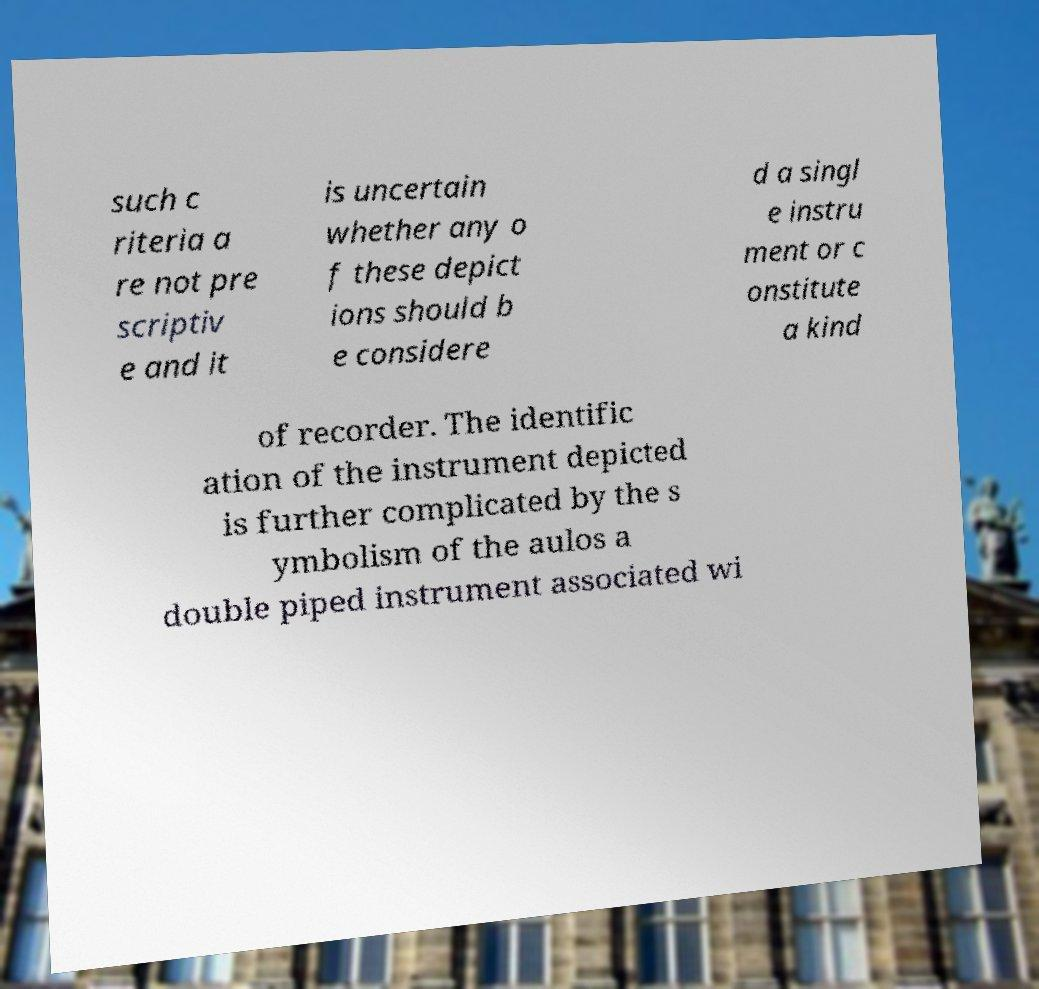For documentation purposes, I need the text within this image transcribed. Could you provide that? such c riteria a re not pre scriptiv e and it is uncertain whether any o f these depict ions should b e considere d a singl e instru ment or c onstitute a kind of recorder. The identific ation of the instrument depicted is further complicated by the s ymbolism of the aulos a double piped instrument associated wi 